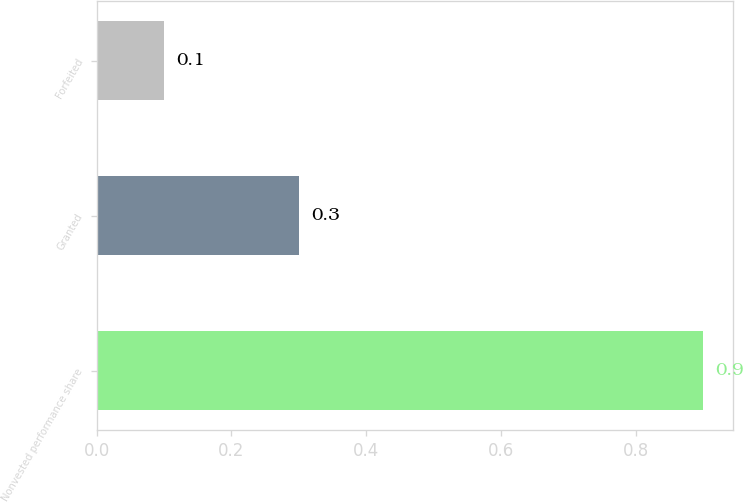Convert chart to OTSL. <chart><loc_0><loc_0><loc_500><loc_500><bar_chart><fcel>Nonvested performance share<fcel>Granted<fcel>Forfeited<nl><fcel>0.9<fcel>0.3<fcel>0.1<nl></chart> 